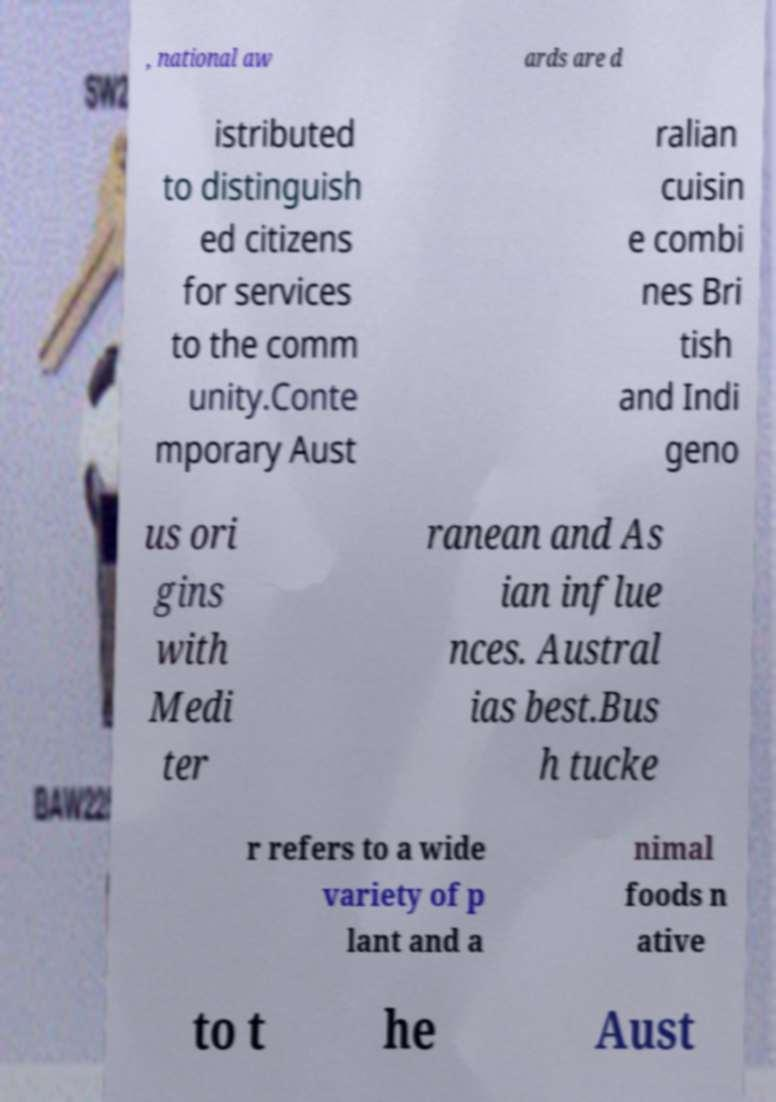For documentation purposes, I need the text within this image transcribed. Could you provide that? , national aw ards are d istributed to distinguish ed citizens for services to the comm unity.Conte mporary Aust ralian cuisin e combi nes Bri tish and Indi geno us ori gins with Medi ter ranean and As ian influe nces. Austral ias best.Bus h tucke r refers to a wide variety of p lant and a nimal foods n ative to t he Aust 